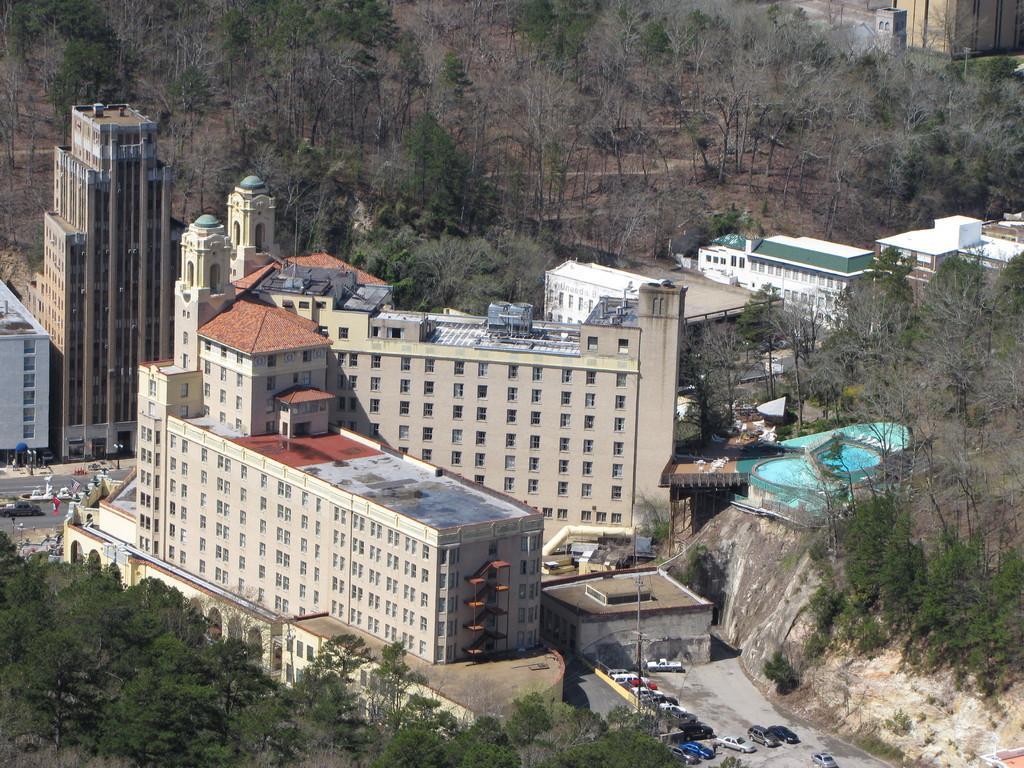Could you give a brief overview of what you see in this image? In the middle of the image we can see some trees, buildings, vehicles and poles. 